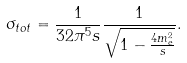<formula> <loc_0><loc_0><loc_500><loc_500>\sigma _ { t o t } = \frac { 1 } { 3 2 \pi ^ { 5 } s } \frac { 1 } { \sqrt { 1 - \frac { 4 m _ { e } ^ { 2 } } { s } } } .</formula> 